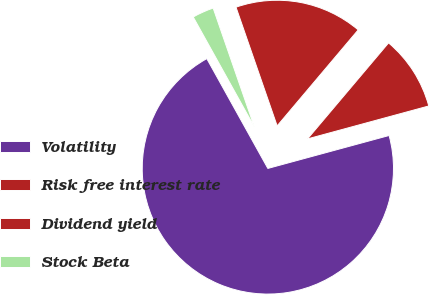<chart> <loc_0><loc_0><loc_500><loc_500><pie_chart><fcel>Volatility<fcel>Risk free interest rate<fcel>Dividend yield<fcel>Stock Beta<nl><fcel>71.15%<fcel>9.62%<fcel>16.47%<fcel>2.77%<nl></chart> 